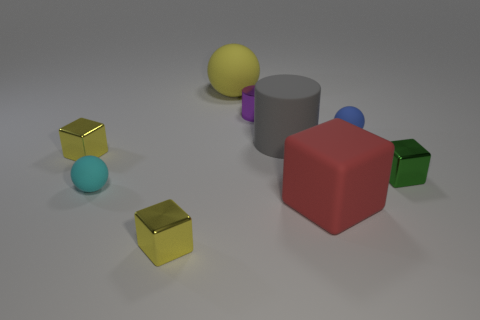What number of objects are both on the right side of the yellow matte sphere and in front of the tiny green thing?
Provide a short and direct response. 1. There is a large rubber sphere; does it have the same color as the tiny shiny object that is to the left of the cyan ball?
Your answer should be compact. Yes. The small matte object that is to the left of the metallic cylinder has what shape?
Your answer should be very brief. Sphere. What number of other objects are there of the same material as the large yellow object?
Offer a terse response. 4. What is the material of the tiny blue ball?
Your answer should be very brief. Rubber. How many tiny objects are either green cylinders or yellow rubber things?
Provide a succinct answer. 0. There is a blue object; how many purple cylinders are behind it?
Your answer should be very brief. 1. Are there any tiny things of the same color as the large sphere?
Provide a succinct answer. Yes. There is a blue rubber object that is the same size as the cyan ball; what shape is it?
Your response must be concise. Sphere. What number of purple objects are either big rubber things or small metallic objects?
Your response must be concise. 1. 